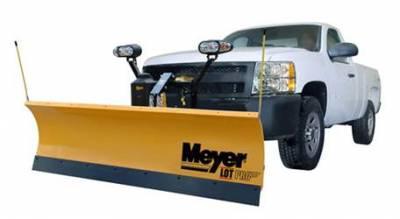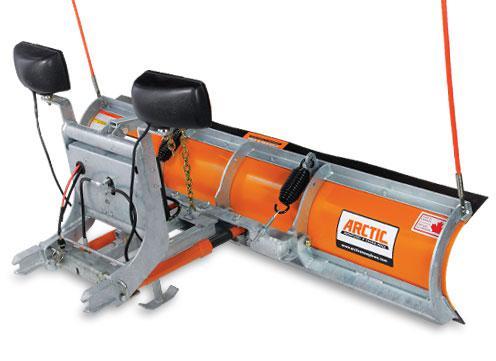The first image is the image on the left, the second image is the image on the right. Considering the images on both sides, is "One image shows an orange plow that is not attached to a vehicle." valid? Answer yes or no. Yes. The first image is the image on the left, the second image is the image on the right. Evaluate the accuracy of this statement regarding the images: "One image shows a complete angled side view of a pickup truck with a front snow blade, while a second image shows an unattached orange snow blade.". Is it true? Answer yes or no. Yes. 